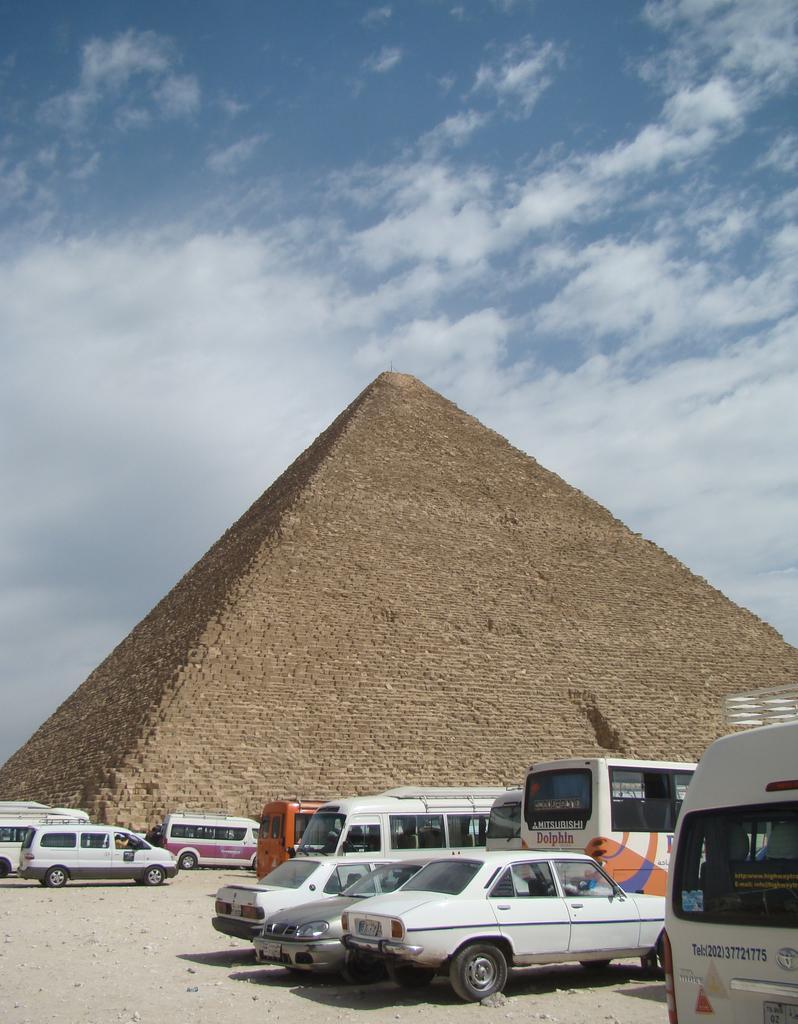Describe this image in one or two sentences. In this image I can see a pyramid. At the bottom there are few cars. At the top I can see clouds in the sky. 